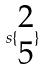<formula> <loc_0><loc_0><loc_500><loc_500>s \{ \begin{matrix} 2 \\ 5 \end{matrix} \}</formula> 